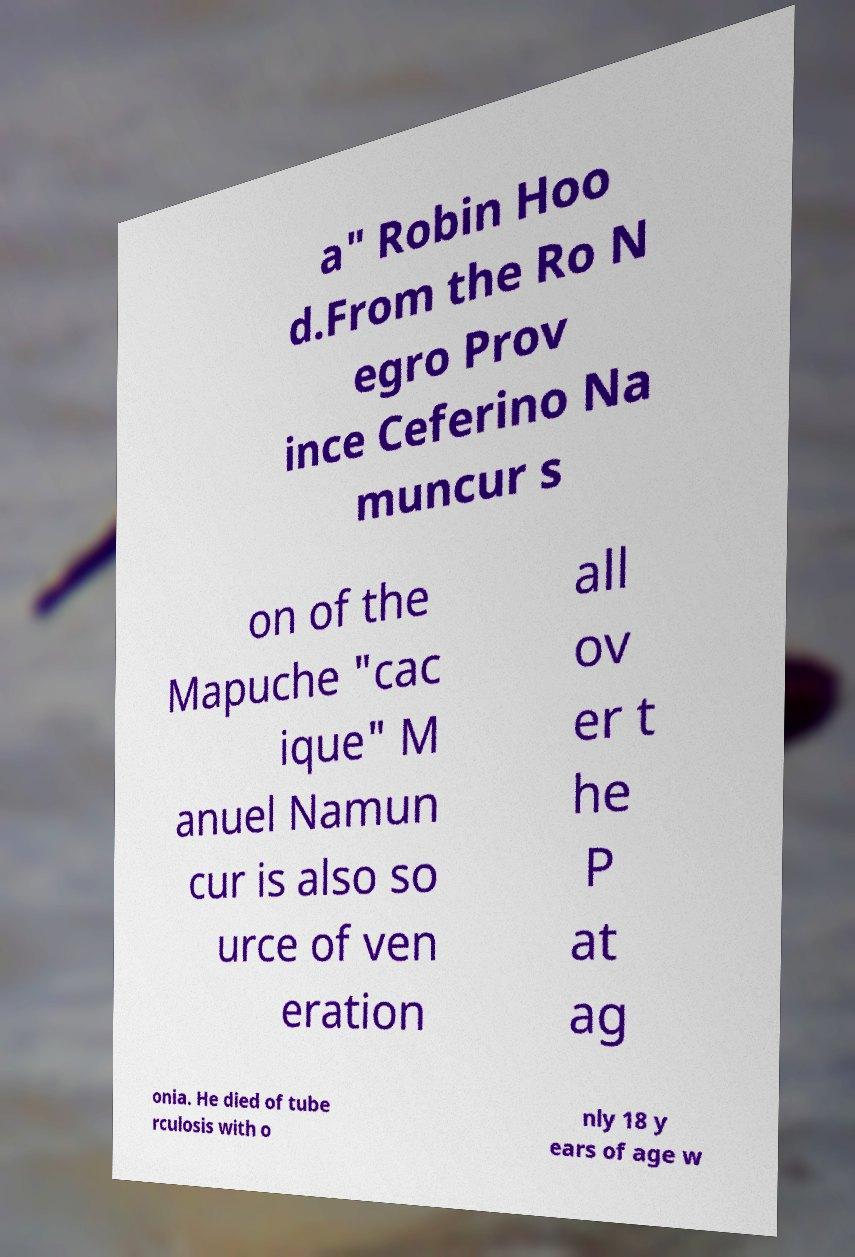I need the written content from this picture converted into text. Can you do that? a" Robin Hoo d.From the Ro N egro Prov ince Ceferino Na muncur s on of the Mapuche "cac ique" M anuel Namun cur is also so urce of ven eration all ov er t he P at ag onia. He died of tube rculosis with o nly 18 y ears of age w 